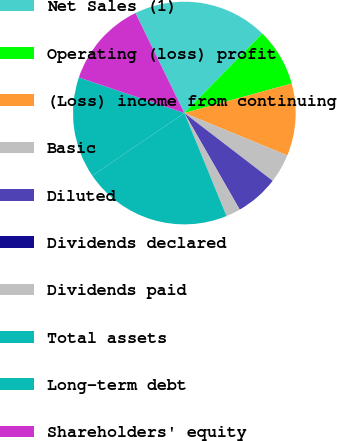<chart> <loc_0><loc_0><loc_500><loc_500><pie_chart><fcel>Net Sales (1)<fcel>Operating (loss) profit<fcel>(Loss) income from continuing<fcel>Basic<fcel>Diluted<fcel>Dividends declared<fcel>Dividends paid<fcel>Total assets<fcel>Long-term debt<fcel>Shareholders' equity<nl><fcel>19.57%<fcel>8.39%<fcel>10.49%<fcel>4.2%<fcel>6.3%<fcel>0.0%<fcel>2.1%<fcel>21.67%<fcel>14.69%<fcel>12.59%<nl></chart> 